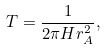<formula> <loc_0><loc_0><loc_500><loc_500>T = \frac { 1 } { 2 \pi H r _ { A } ^ { 2 } } ,</formula> 